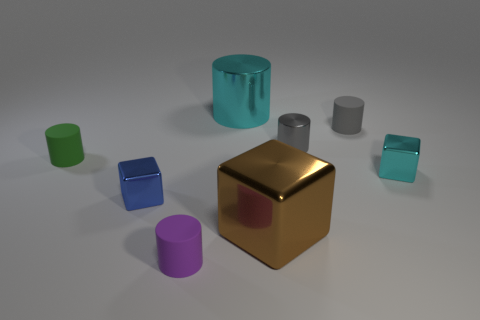There is a purple cylinder that is in front of the tiny cylinder left of the blue cube; is there a object that is behind it?
Keep it short and to the point. Yes. What is the shape of the small purple object that is the same material as the green cylinder?
Offer a very short reply. Cylinder. The large brown shiny thing is what shape?
Your response must be concise. Cube. There is a cyan object that is right of the large brown object; does it have the same shape as the big cyan object?
Keep it short and to the point. No. Are there more cyan things that are on the right side of the brown block than gray shiny cylinders that are behind the tiny gray rubber object?
Make the answer very short. Yes. What number of other things are the same size as the gray matte thing?
Provide a succinct answer. 5. There is a large brown object; is it the same shape as the rubber object that is to the left of the purple thing?
Give a very brief answer. No. What number of metallic things are small green objects or small cyan cubes?
Make the answer very short. 1. Is there a tiny metallic thing that has the same color as the large metal cylinder?
Keep it short and to the point. Yes. Is there a big yellow metal cube?
Give a very brief answer. No. 